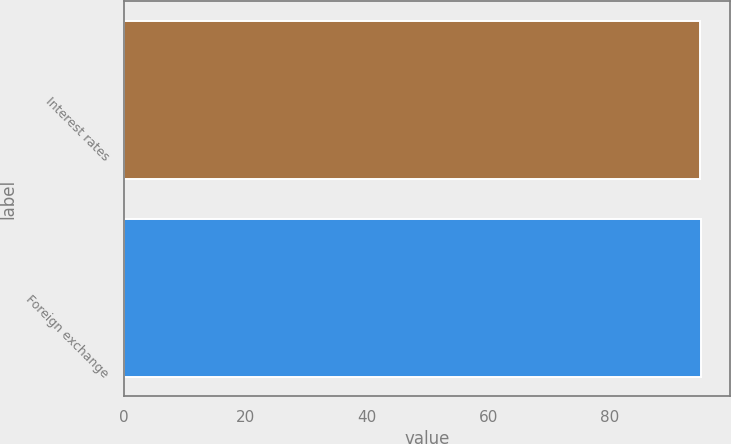<chart> <loc_0><loc_0><loc_500><loc_500><bar_chart><fcel>Interest rates<fcel>Foreign exchange<nl><fcel>95<fcel>95.1<nl></chart> 